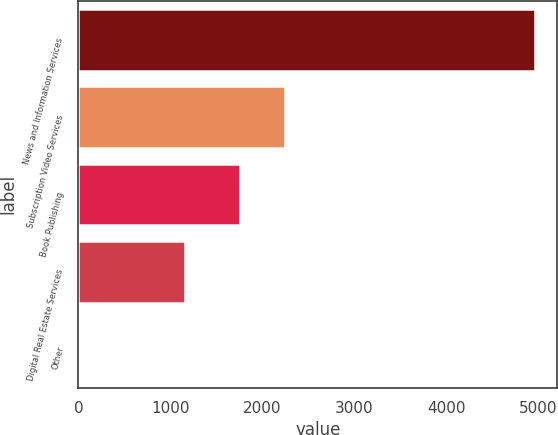Convert chart to OTSL. <chart><loc_0><loc_0><loc_500><loc_500><bar_chart><fcel>News and Information Services<fcel>Subscription Video Services<fcel>Book Publishing<fcel>Digital Real Estate Services<fcel>Other<nl><fcel>4956<fcel>2249.3<fcel>1754<fcel>1159<fcel>3<nl></chart> 